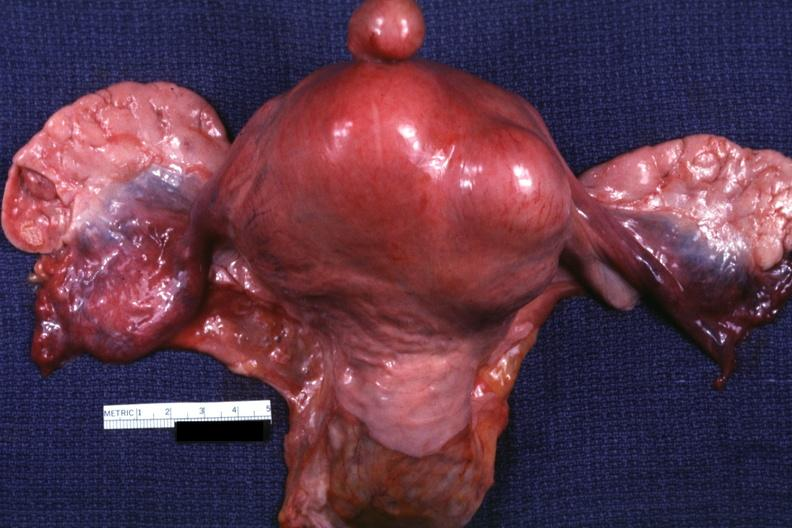what is this one pedunculated myoma?
Answer the question using a single word or phrase. A good example 